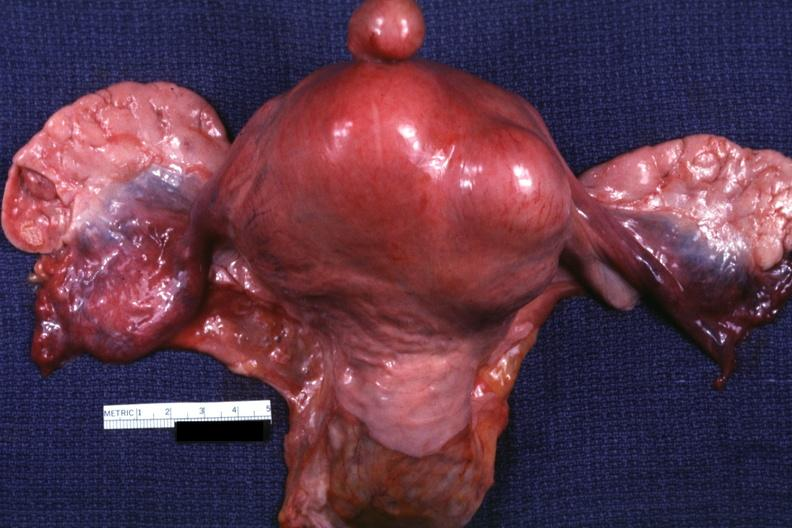what is this one pedunculated myoma?
Answer the question using a single word or phrase. A good example 